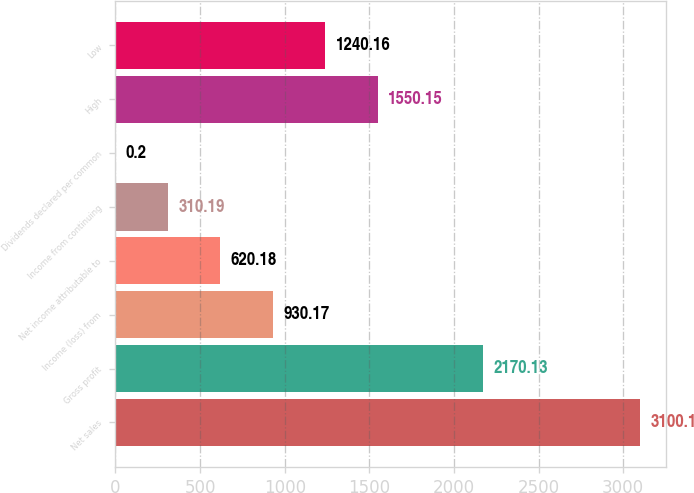<chart> <loc_0><loc_0><loc_500><loc_500><bar_chart><fcel>Net sales<fcel>Gross profit<fcel>Income (loss) from<fcel>Net income attributable to<fcel>Income from continuing<fcel>Dividends declared per common<fcel>High<fcel>Low<nl><fcel>3100.1<fcel>2170.13<fcel>930.17<fcel>620.18<fcel>310.19<fcel>0.2<fcel>1550.15<fcel>1240.16<nl></chart> 